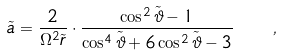<formula> <loc_0><loc_0><loc_500><loc_500>\tilde { a } = \frac { 2 } { \Omega ^ { 2 } \tilde { r } } \cdot \frac { \cos ^ { 2 } \tilde { \vartheta } - 1 } { \cos ^ { 4 } \tilde { \vartheta } + 6 \cos ^ { 2 } \tilde { \vartheta } - 3 } \quad ,</formula> 